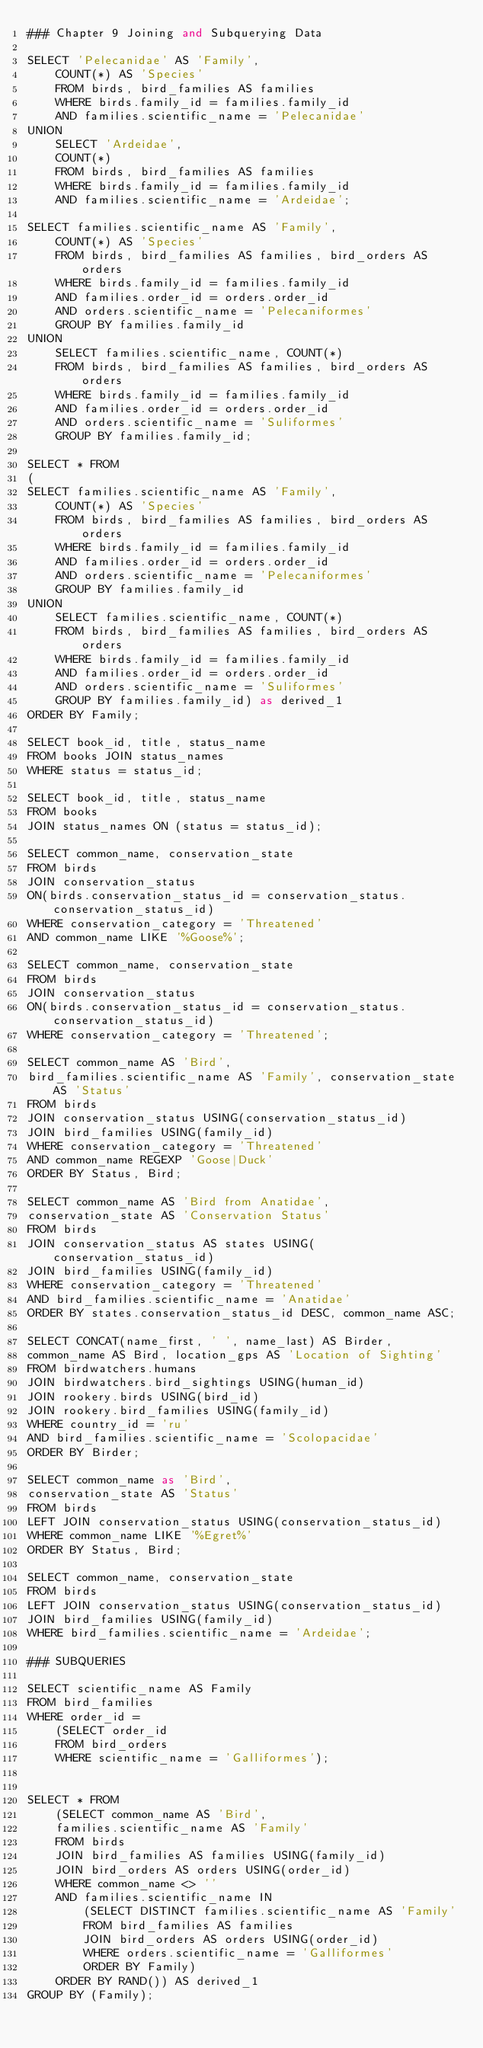Convert code to text. <code><loc_0><loc_0><loc_500><loc_500><_SQL_>### Chapter 9 Joining and Subquerying Data

SELECT 'Pelecanidae' AS 'Family',
    COUNT(*) AS 'Species'
    FROM birds, bird_families AS families
    WHERE birds.family_id = families.family_id
    AND families.scientific_name = 'Pelecanidae'
UNION
    SELECT 'Ardeidae',
    COUNT(*)
    FROM birds, bird_families AS families
    WHERE birds.family_id = families.family_id
    AND families.scientific_name = 'Ardeidae';

SELECT families.scientific_name AS 'Family',
    COUNT(*) AS 'Species'
    FROM birds, bird_families AS families, bird_orders AS orders
    WHERE birds.family_id = families.family_id
    AND families.order_id = orders.order_id
    AND orders.scientific_name = 'Pelecaniformes'
    GROUP BY families.family_id
UNION
    SELECT families.scientific_name, COUNT(*)
    FROM birds, bird_families AS families, bird_orders AS orders
    WHERE birds.family_id = families.family_id
    AND families.order_id = orders.order_id
    AND orders.scientific_name = 'Suliformes'
    GROUP BY families.family_id;

SELECT * FROM
(
SELECT families.scientific_name AS 'Family',
    COUNT(*) AS 'Species'
    FROM birds, bird_families AS families, bird_orders AS orders
    WHERE birds.family_id = families.family_id
    AND families.order_id = orders.order_id
    AND orders.scientific_name = 'Pelecaniformes'
    GROUP BY families.family_id
UNION
    SELECT families.scientific_name, COUNT(*)
    FROM birds, bird_families AS families, bird_orders AS orders
    WHERE birds.family_id = families.family_id
    AND families.order_id = orders.order_id
    AND orders.scientific_name = 'Suliformes'
    GROUP BY families.family_id) as derived_1
ORDER BY Family;

SELECT book_id, title, status_name
FROM books JOIN status_names
WHERE status = status_id;

SELECT book_id, title, status_name
FROM books
JOIN status_names ON (status = status_id);

SELECT common_name, conservation_state
FROM birds
JOIN conservation_status
ON(birds.conservation_status_id = conservation_status.conservation_status_id)
WHERE conservation_category = 'Threatened'
AND common_name LIKE '%Goose%';

SELECT common_name, conservation_state
FROM birds
JOIN conservation_status
ON(birds.conservation_status_id = conservation_status.conservation_status_id)
WHERE conservation_category = 'Threatened';

SELECT common_name AS 'Bird',
bird_families.scientific_name AS 'Family', conservation_state AS 'Status'
FROM birds
JOIN conservation_status USING(conservation_status_id)
JOIN bird_families USING(family_id)
WHERE conservation_category = 'Threatened'
AND common_name REGEXP 'Goose|Duck'
ORDER BY Status, Bird;

SELECT common_name AS 'Bird from Anatidae',
conservation_state AS 'Conservation Status'
FROM birds
JOIN conservation_status AS states USING(conservation_status_id)
JOIN bird_families USING(family_id)
WHERE conservation_category = 'Threatened'
AND bird_families.scientific_name = 'Anatidae'
ORDER BY states.conservation_status_id DESC, common_name ASC;

SELECT CONCAT(name_first, ' ', name_last) AS Birder,
common_name AS Bird, location_gps AS 'Location of Sighting'
FROM birdwatchers.humans
JOIN birdwatchers.bird_sightings USING(human_id)
JOIN rookery.birds USING(bird_id)
JOIN rookery.bird_families USING(family_id)
WHERE country_id = 'ru'
AND bird_families.scientific_name = 'Scolopacidae'
ORDER BY Birder;

SELECT common_name as 'Bird',
conservation_state AS 'Status'
FROM birds
LEFT JOIN conservation_status USING(conservation_status_id)
WHERE common_name LIKE '%Egret%'
ORDER BY Status, Bird;

SELECT common_name, conservation_state
FROM birds
LEFT JOIN conservation_status USING(conservation_status_id)
JOIN bird_families USING(family_id)
WHERE bird_families.scientific_name = 'Ardeidae';

### SUBQUERIES

SELECT scientific_name AS Family
FROM bird_families
WHERE order_id = 
    (SELECT order_id
    FROM bird_orders
    WHERE scientific_name = 'Galliformes');


SELECT * FROM 
    (SELECT common_name AS 'Bird',
    families.scientific_name AS 'Family'
    FROM birds
    JOIN bird_families AS families USING(family_id)
    JOIN bird_orders AS orders USING(order_id)
    WHERE common_name <> ''
    AND families.scientific_name IN
        (SELECT DISTINCT families.scientific_name AS 'Family'
        FROM bird_families AS families
        JOIN bird_orders AS orders USING(order_id)
        WHERE orders.scientific_name = 'Galliformes'
        ORDER BY Family)
    ORDER BY RAND()) AS derived_1
GROUP BY (Family);
</code> 